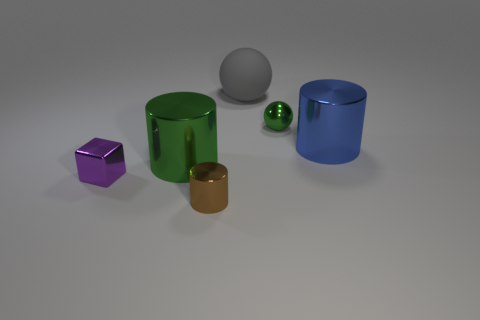Is the number of metal objects that are left of the blue shiny thing greater than the number of tiny metal balls?
Make the answer very short. Yes. What number of other things are there of the same color as the metallic sphere?
Keep it short and to the point. 1. There is a purple object that is the same size as the brown object; what shape is it?
Keep it short and to the point. Cube. How many large cylinders are in front of the large metal cylinder right of the green shiny object that is in front of the tiny green metal thing?
Offer a terse response. 1. What number of rubber objects are large blue cylinders or big objects?
Your answer should be compact. 1. What is the color of the small object that is behind the small shiny cylinder and to the right of the big green metallic cylinder?
Your answer should be very brief. Green. There is a cylinder that is on the right side of the green sphere; is its size the same as the large gray rubber object?
Offer a terse response. Yes. How many things are either spheres to the left of the small green metal ball or green balls?
Provide a short and direct response. 2. Is there a gray thing that has the same size as the blue object?
Make the answer very short. Yes. There is a green object that is the same size as the purple object; what material is it?
Your response must be concise. Metal. 